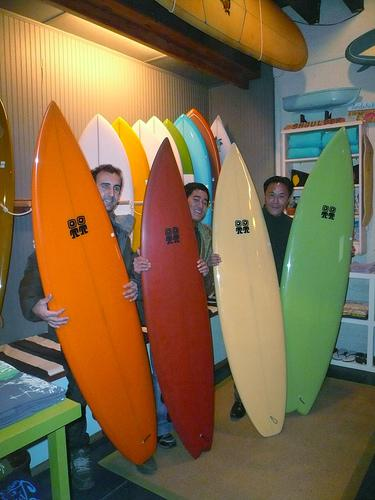Question: how many surfboards are the men holding?
Choices:
A. Four.
B. Three.
C. Two.
D. Five.
Answer with the letter. Answer: A Question: what are the men standing on?
Choices:
A. Dock.
B. The grass.
C. Beach.
D. A rug.
Answer with the letter. Answer: D Question: what color is the surfboard on the far left?
Choices:
A. Blue.
B. Orange.
C. Yellow.
D. Red.
Answer with the letter. Answer: B Question: what are the men holding?
Choices:
A. Surfboards.
B. Children.
C. Beakers.
D. Cell phone.
Answer with the letter. Answer: A Question: how many people are in this photo?
Choices:
A. Two.
B. None.
C. Three.
D. Four.
Answer with the letter. Answer: C Question: who is in this photo?
Choices:
A. Three men.
B. Family.
C. Children.
D. Two women.
Answer with the letter. Answer: A Question: where was this photo taken?
Choices:
A. House.
B. In a surf shop.
C. Outside.
D. Forest.
Answer with the letter. Answer: B 